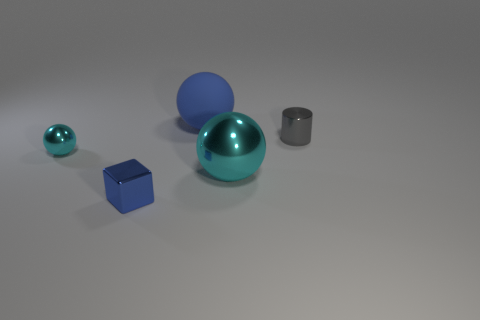How many other objects are the same size as the rubber ball?
Your answer should be very brief. 1. What number of tiny objects are blue metal blocks or yellow cubes?
Give a very brief answer. 1. Is the size of the blue matte thing the same as the blue thing that is in front of the tiny gray metal thing?
Offer a terse response. No. How many other things are the same shape as the gray shiny thing?
Give a very brief answer. 0. There is a small gray object that is made of the same material as the large cyan ball; what is its shape?
Give a very brief answer. Cylinder. Are any big yellow rubber cubes visible?
Offer a terse response. No. Is the number of gray shiny cylinders in front of the gray cylinder less than the number of gray cylinders in front of the large cyan shiny ball?
Offer a very short reply. No. There is a big object on the right side of the blue ball; what shape is it?
Offer a very short reply. Sphere. Are the small cylinder and the blue cube made of the same material?
Make the answer very short. Yes. Is there any other thing that is the same material as the tiny cyan ball?
Keep it short and to the point. Yes. 